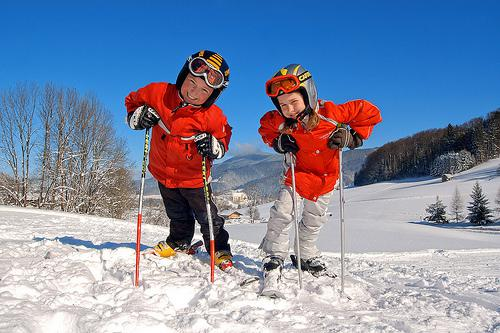Question: what color is the sky?
Choices:
A. White.
B. Black.
C. Gray.
D. Blue.
Answer with the letter. Answer: D Question: why are the kids wearing ski gear?
Choices:
A. To play.
B. They're skiing.
C. To have fun.
D. To go down the slopes.
Answer with the letter. Answer: B Question: who is wearing ski gear?
Choices:
A. The people.
B. The person.
C. The kids.
D. The woman.
Answer with the letter. Answer: C Question: what color are the kids' coats?
Choices:
A. Blue.
B. Red.
C. Orange.
D. Yellow.
Answer with the letter. Answer: C 